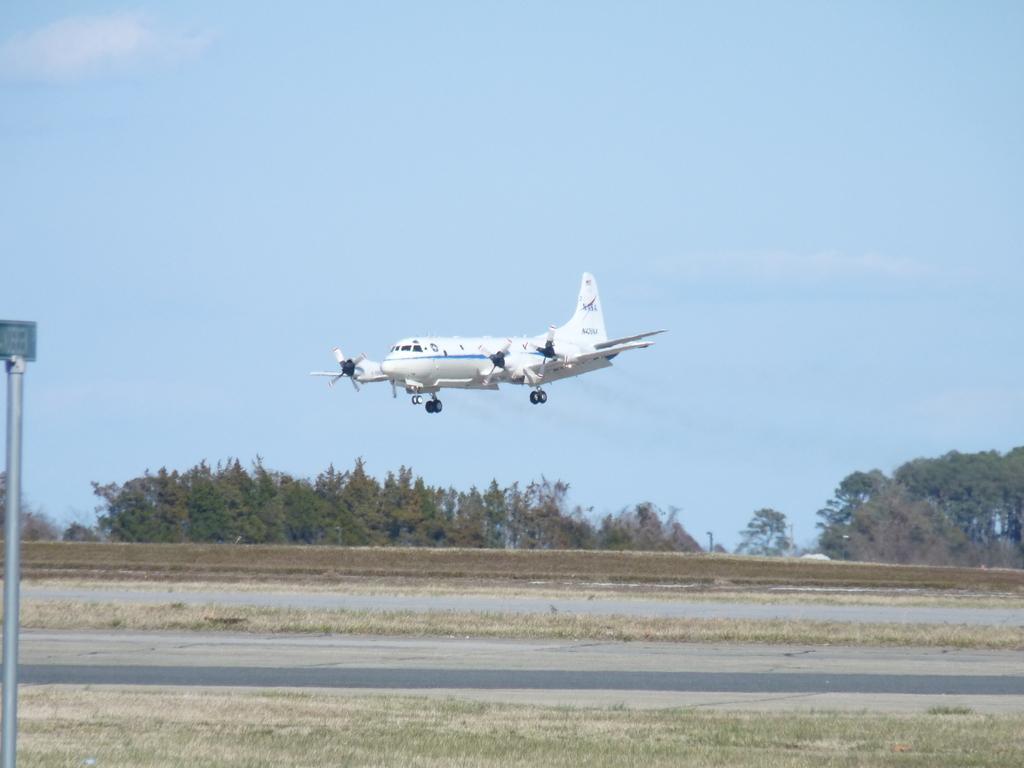Can you describe this image briefly? In this image, we can see an aeroplane in the sky and there is a name board and we can see trees. At the bottom, there is ground and a road. 